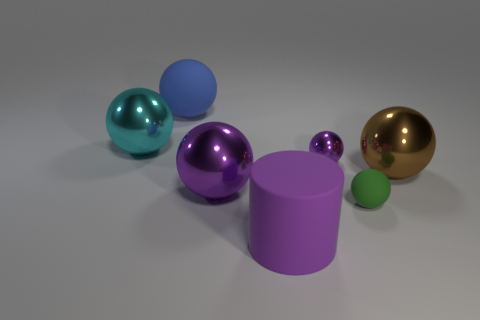Is the material of the large blue object the same as the tiny sphere in front of the brown metal thing?
Ensure brevity in your answer.  Yes. The tiny matte ball has what color?
Provide a succinct answer. Green. There is a cylinder to the left of the purple ball that is behind the purple metallic thing that is in front of the tiny purple sphere; what color is it?
Your answer should be very brief. Purple. Does the large blue rubber object have the same shape as the large rubber thing in front of the tiny purple metallic thing?
Provide a succinct answer. No. There is a shiny object that is both behind the big brown ball and on the left side of the cylinder; what color is it?
Ensure brevity in your answer.  Cyan. Is there a tiny brown thing of the same shape as the small green thing?
Provide a succinct answer. No. Does the large rubber cylinder have the same color as the tiny shiny sphere?
Offer a very short reply. Yes. Are there any small shiny spheres that are to the left of the rubber ball that is behind the big cyan sphere?
Give a very brief answer. No. How many things are big things that are to the left of the brown object or things to the left of the large purple cylinder?
Provide a short and direct response. 4. How many things are large blue matte spheres or large objects that are to the right of the cylinder?
Your answer should be compact. 2. 